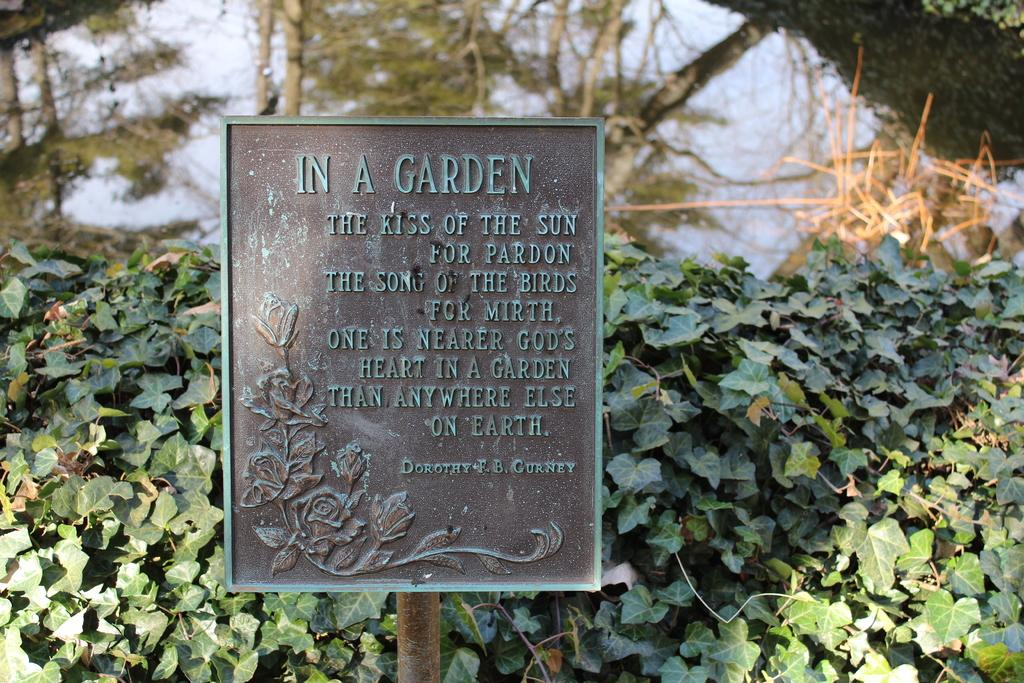What is attached to the pole in the image? There is a board attached to a pole in the image. What can be seen in the background of the image? There are trees and the sky visible in the background of the image. What is the color of the trees in the image? The trees are green in the image. What is the color of the sky in the image? The sky is blue in the image. What type of poison is being used to protect the trees in the image? There is no mention of poison or any protective measures for the trees in the image. 